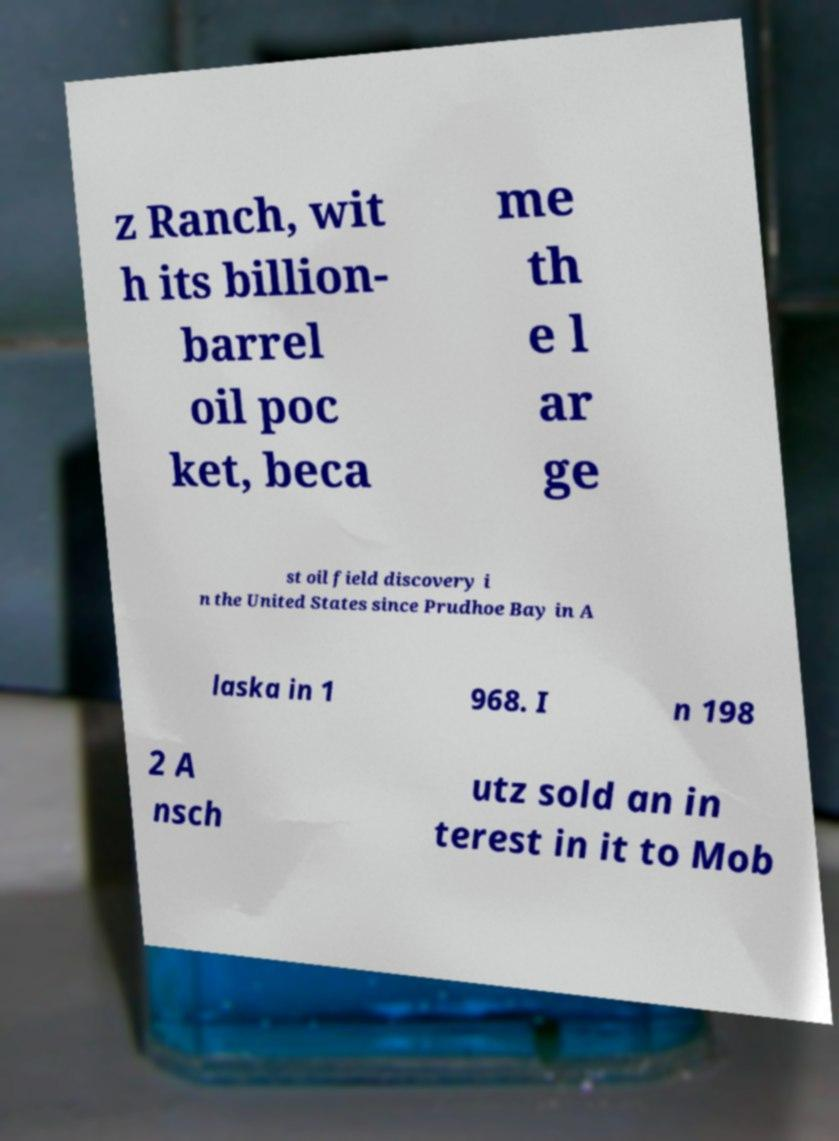I need the written content from this picture converted into text. Can you do that? z Ranch, wit h its billion- barrel oil poc ket, beca me th e l ar ge st oil field discovery i n the United States since Prudhoe Bay in A laska in 1 968. I n 198 2 A nsch utz sold an in terest in it to Mob 